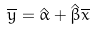Convert formula to latex. <formula><loc_0><loc_0><loc_500><loc_500>\overline { y } = \hat { \alpha } + \hat { \beta } \overline { x }</formula> 